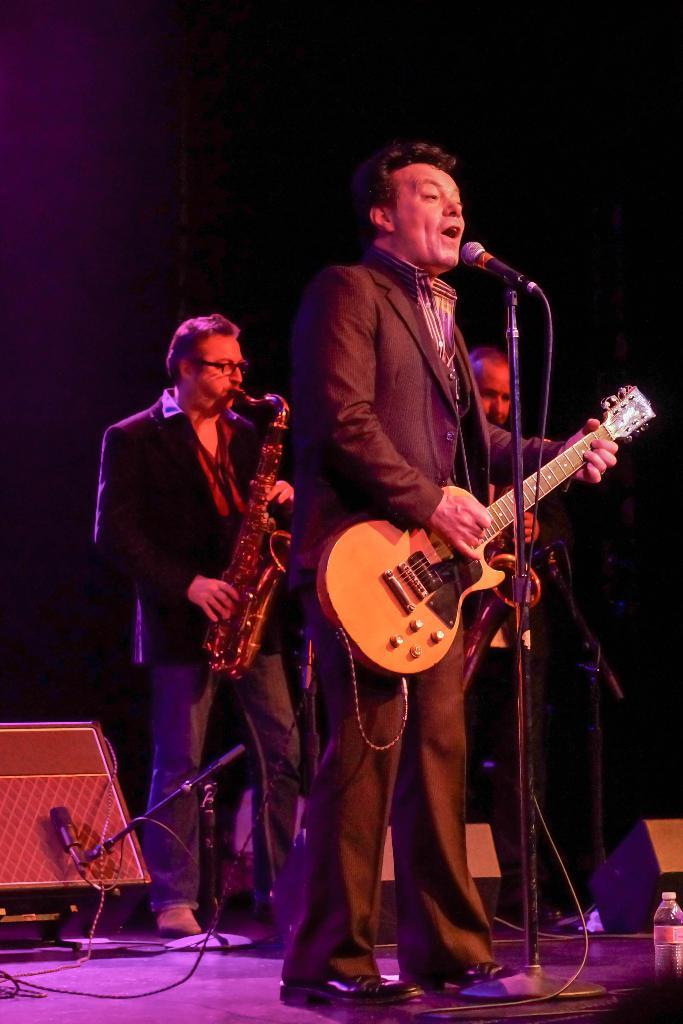What object can be seen in the image that is typically used for holding liquids? There is a bottle in the image. What objects are present in the image that are commonly used for amplifying sound? There are speakers in the image. What objects are present in the image that are used for capturing sound? There are microphones in the image. What type of objects are present in the image that are used for connecting and transmitting electrical signals? There are wires in the image. What object can be seen in the image that is used for correcting vision? There is a pair of spectacles in the image. How many men are in the image? There are three men in the image. What are the men in the image doing? The men are holding musical instruments and standing. What is the color of the background in the image? The background of the image is dark. How many cakes are being served on the table in the image? There is no table or cakes present in the image. What type of bell can be heard ringing in the background of the image? There is no bell present in the image, and therefore no sound can be heard. 